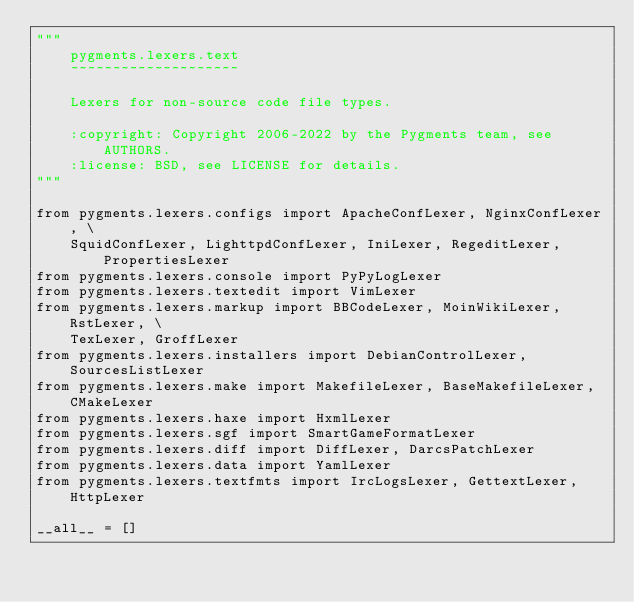Convert code to text. <code><loc_0><loc_0><loc_500><loc_500><_Python_>"""
    pygments.lexers.text
    ~~~~~~~~~~~~~~~~~~~~

    Lexers for non-source code file types.

    :copyright: Copyright 2006-2022 by the Pygments team, see AUTHORS.
    :license: BSD, see LICENSE for details.
"""

from pygments.lexers.configs import ApacheConfLexer, NginxConfLexer, \
    SquidConfLexer, LighttpdConfLexer, IniLexer, RegeditLexer, PropertiesLexer
from pygments.lexers.console import PyPyLogLexer
from pygments.lexers.textedit import VimLexer
from pygments.lexers.markup import BBCodeLexer, MoinWikiLexer, RstLexer, \
    TexLexer, GroffLexer
from pygments.lexers.installers import DebianControlLexer, SourcesListLexer
from pygments.lexers.make import MakefileLexer, BaseMakefileLexer, CMakeLexer
from pygments.lexers.haxe import HxmlLexer
from pygments.lexers.sgf import SmartGameFormatLexer
from pygments.lexers.diff import DiffLexer, DarcsPatchLexer
from pygments.lexers.data import YamlLexer
from pygments.lexers.textfmts import IrcLogsLexer, GettextLexer, HttpLexer

__all__ = []
</code> 